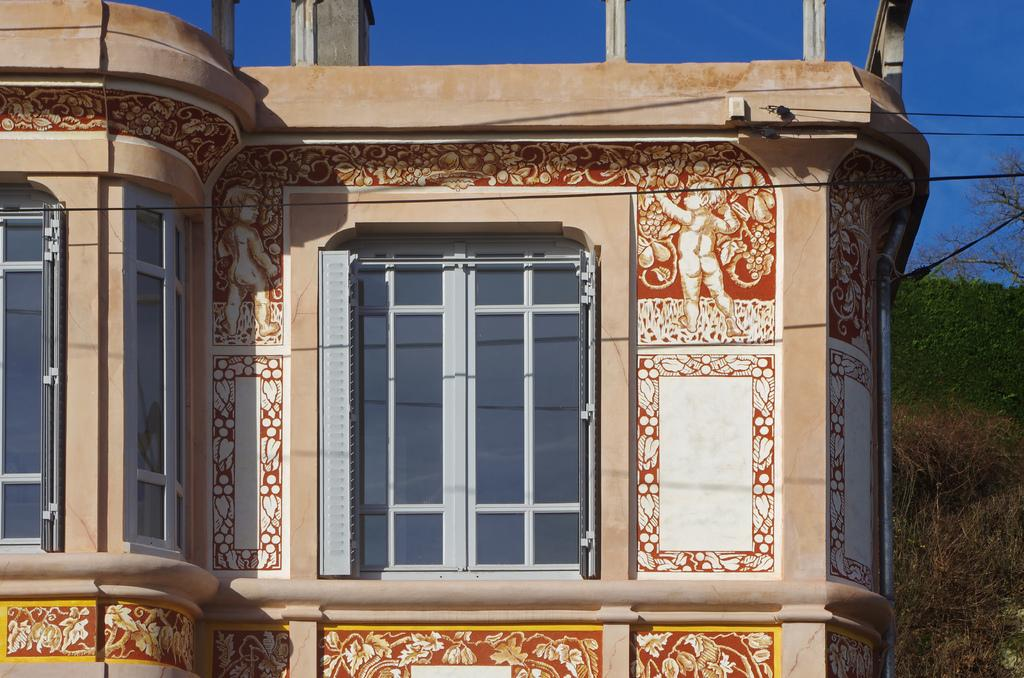What structure is the main subject of the image? There is a building in the image. What feature can be seen on the building? The building has windows. What type of vegetation is on the right side of the image? There are trees on the right side of the image. What is visible at the top of the image? The sky is visible at the top of the image, and there are also wires visible. What is the building's opinion on the coach's latest decision in the image? The building is an inanimate object and does not have an opinion or mind to form one. Can you tell me how many times the building jumps in the image? Buildings do not jump, as they are stationary structures. 